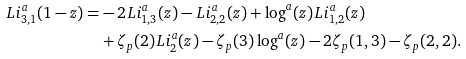<formula> <loc_0><loc_0><loc_500><loc_500>L i ^ { a } _ { 3 , 1 } ( 1 - z ) = & - 2 L i ^ { a } _ { 1 , 3 } ( z ) - L i ^ { a } _ { 2 , 2 } ( z ) + \log ^ { a } ( z ) L i ^ { a } _ { 1 , 2 } ( z ) \\ & + \zeta _ { p } ( 2 ) L i ^ { a } _ { 2 } ( z ) - \zeta _ { p } ( 3 ) \log ^ { a } ( z ) - 2 \zeta _ { p } ( 1 , 3 ) - \zeta _ { p } ( 2 , 2 ) .</formula> 